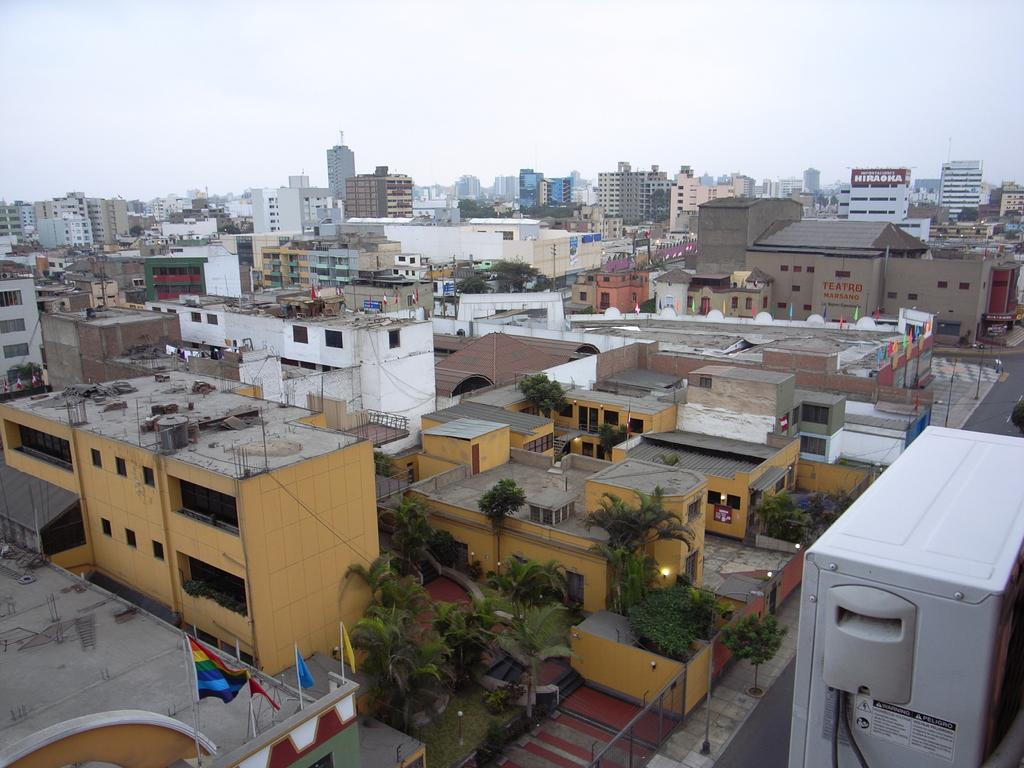What can be seen in the middle of the image? In the middle of the image, there are buildings, trees, flags, poles, lights, and boards with text. What is located on the right side of the image? There is a compressor on the right side of the image. What is visible at the top of the image? The sky is visible at the top of the image. What type of error can be seen in the image? There is no error present in the image. Is there a crown visible in the image? No, there is no crown present in the image. 